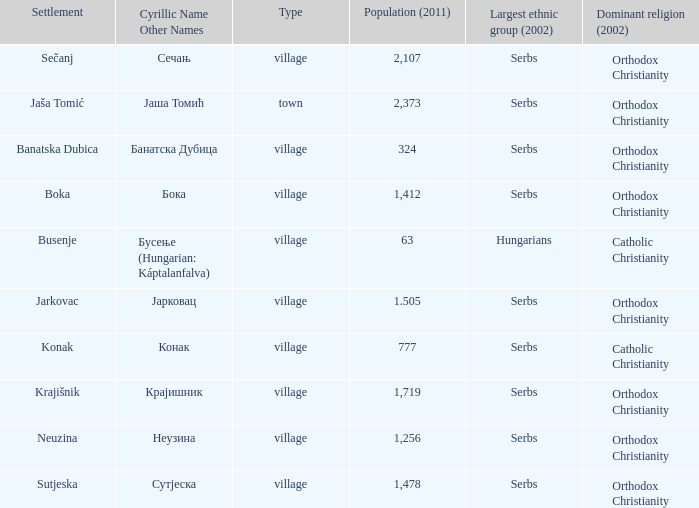What sort of category is бока? Village. 